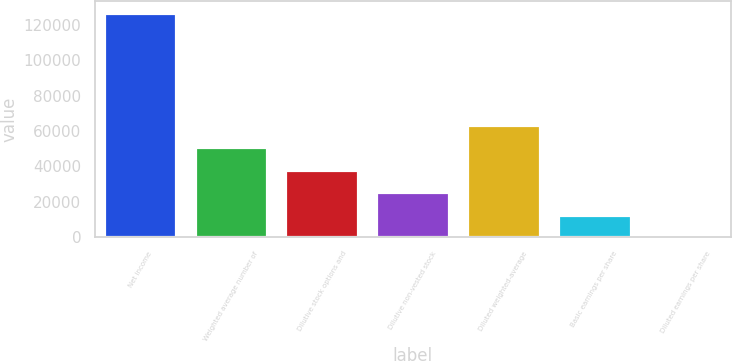Convert chart to OTSL. <chart><loc_0><loc_0><loc_500><loc_500><bar_chart><fcel>Net income<fcel>Weighted average number of<fcel>Dilutive stock options and<fcel>Dilutive non-vested stock<fcel>Diluted weighted-average<fcel>Basic earnings per share<fcel>Diluted earnings per share<nl><fcel>126845<fcel>50740.4<fcel>38056.3<fcel>25372.2<fcel>63424.5<fcel>12688.1<fcel>3.95<nl></chart> 